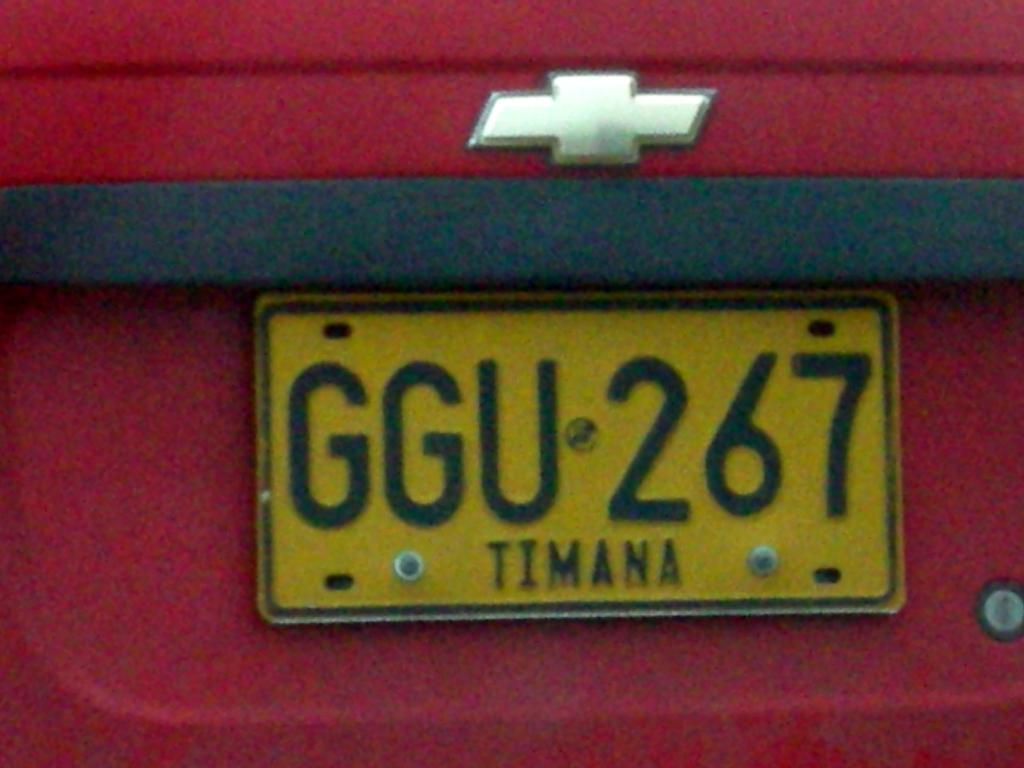Provide a one-sentence caption for the provided image. A license plate marked for an area called Timana is screwed into a red car. 